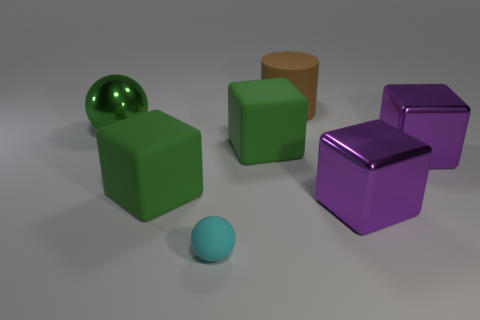Subtract 1 blocks. How many blocks are left? 3 Add 2 matte cylinders. How many objects exist? 9 Subtract all red cubes. Subtract all gray spheres. How many cubes are left? 4 Subtract all cubes. How many objects are left? 3 Add 4 large things. How many large things are left? 10 Add 6 big metal things. How many big metal things exist? 9 Subtract 0 brown blocks. How many objects are left? 7 Subtract all big green balls. Subtract all large things. How many objects are left? 0 